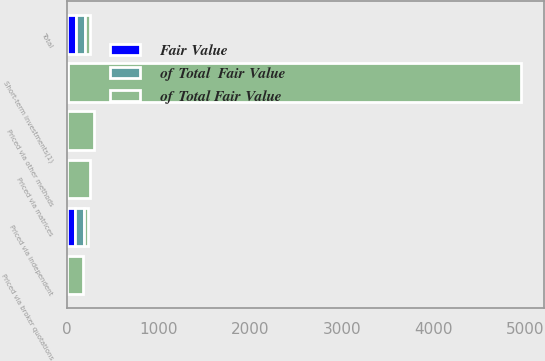Convert chart. <chart><loc_0><loc_0><loc_500><loc_500><stacked_bar_chart><ecel><fcel>Priced via independent<fcel>Priced via broker quotations<fcel>Priced via matrices<fcel>Priced via other methods<fcel>Short-term investments(1)<fcel>Total<nl><fcel>of Total Fair Value<fcel>49.5<fcel>173<fcel>255<fcel>292<fcel>4938<fcel>49.5<nl><fcel>Fair Value<fcel>91.6<fcel>0.3<fcel>0.4<fcel>0.4<fcel>7.3<fcel>100<nl><fcel>of Total  Fair Value<fcel>91.5<fcel>0.3<fcel>0.3<fcel>0.4<fcel>7.5<fcel>100<nl></chart> 